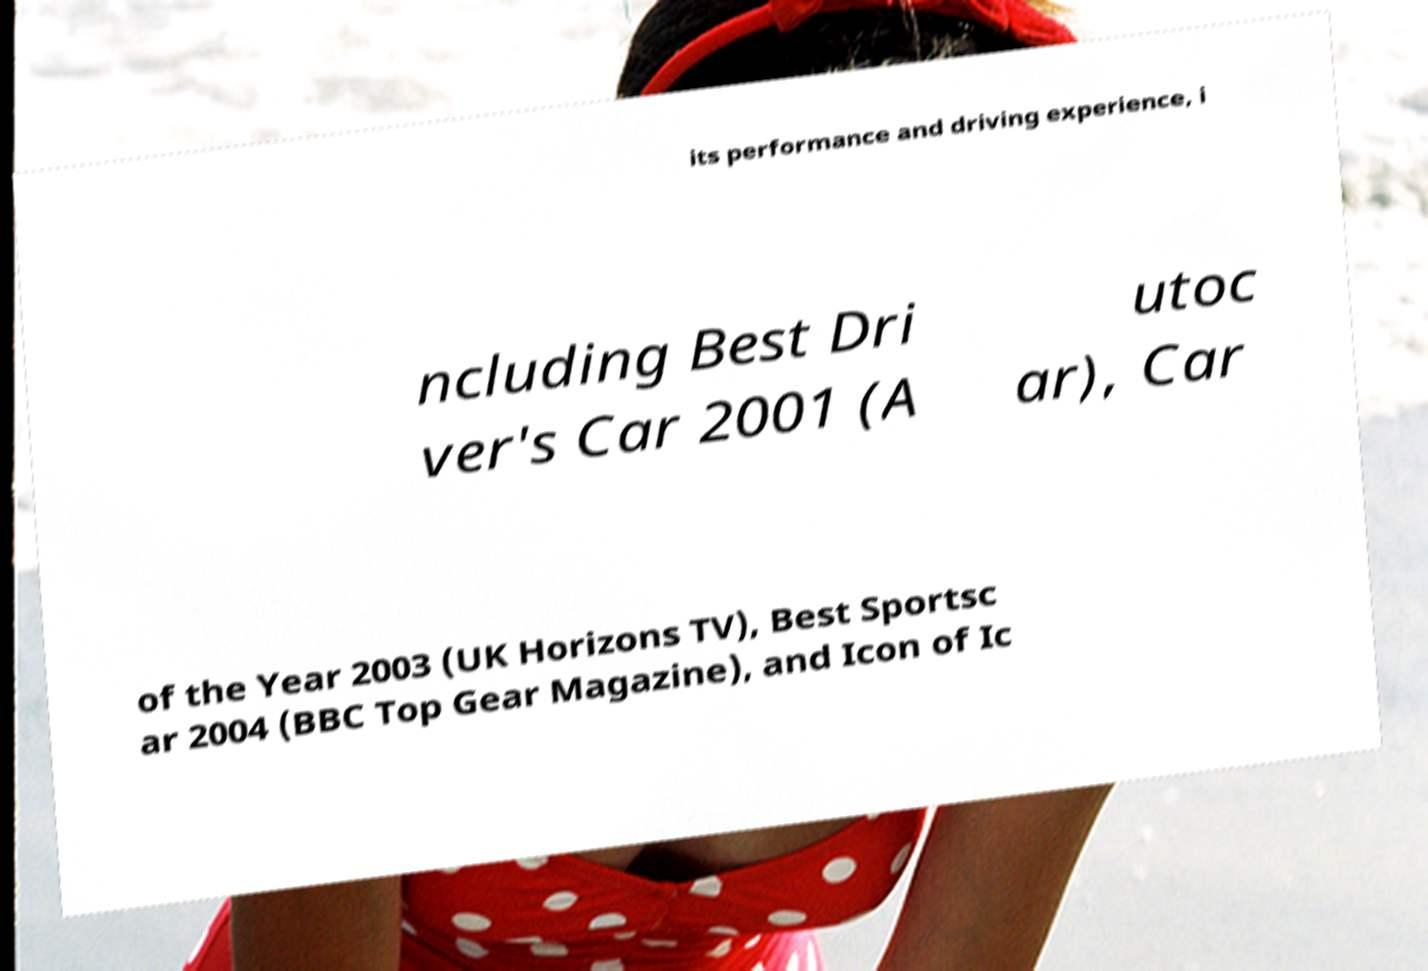For documentation purposes, I need the text within this image transcribed. Could you provide that? its performance and driving experience, i ncluding Best Dri ver's Car 2001 (A utoc ar), Car of the Year 2003 (UK Horizons TV), Best Sportsc ar 2004 (BBC Top Gear Magazine), and Icon of Ic 